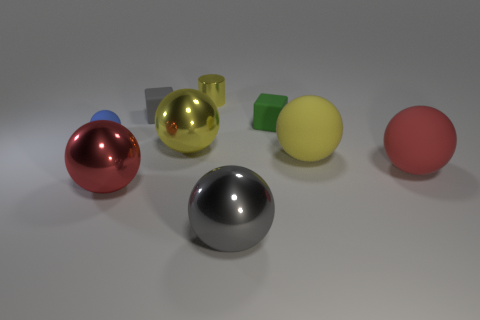How many gray things have the same material as the tiny cylinder?
Your answer should be very brief. 1. Is there a blue shiny block?
Offer a terse response. No. What number of big things have the same color as the cylinder?
Offer a very short reply. 2. Does the green thing have the same material as the big sphere in front of the red metal object?
Make the answer very short. No. Are there more red rubber things in front of the metallic cylinder than shiny cubes?
Make the answer very short. Yes. There is a tiny cylinder; does it have the same color as the large thing behind the big yellow matte sphere?
Offer a very short reply. Yes. Are there the same number of yellow metallic things that are left of the blue ball and small blocks right of the cylinder?
Offer a very short reply. No. What is the gray thing that is behind the blue rubber sphere made of?
Offer a very short reply. Rubber. How many objects are either big metal spheres that are on the left side of the tiny yellow thing or big gray balls?
Give a very brief answer. 3. How many other things are there of the same shape as the blue object?
Offer a very short reply. 5. 